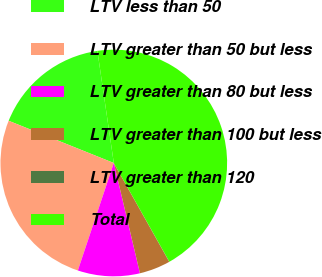<chart> <loc_0><loc_0><loc_500><loc_500><pie_chart><fcel>LTV less than 50<fcel>LTV greater than 50 but less<fcel>LTV greater than 80 but less<fcel>LTV greater than 100 but less<fcel>LTV greater than 120<fcel>Total<nl><fcel>16.61%<fcel>25.94%<fcel>8.85%<fcel>4.43%<fcel>0.02%<fcel>44.16%<nl></chart> 